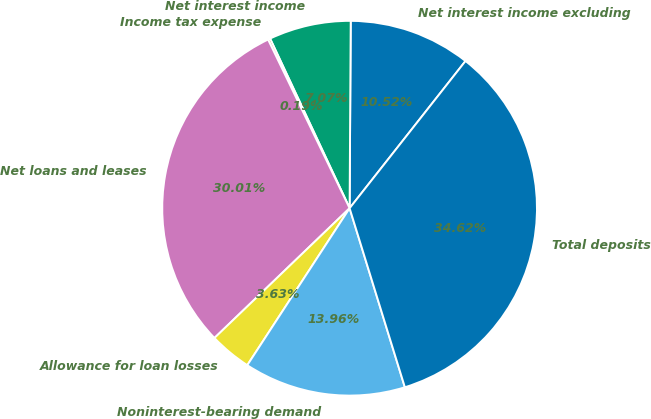Convert chart. <chart><loc_0><loc_0><loc_500><loc_500><pie_chart><fcel>Net interest income excluding<fcel>Net interest income<fcel>Income tax expense<fcel>Net loans and leases<fcel>Allowance for loan losses<fcel>Noninterest-bearing demand<fcel>Total deposits<nl><fcel>10.52%<fcel>7.07%<fcel>0.19%<fcel>30.01%<fcel>3.63%<fcel>13.96%<fcel>34.62%<nl></chart> 